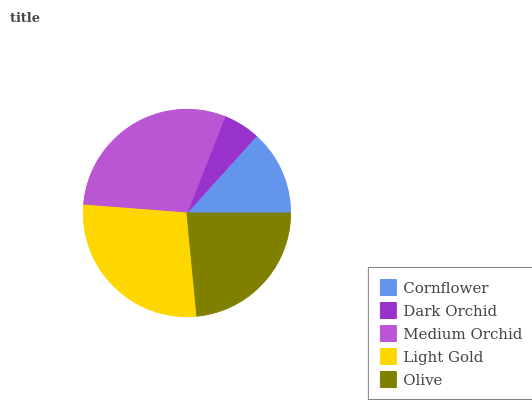Is Dark Orchid the minimum?
Answer yes or no. Yes. Is Medium Orchid the maximum?
Answer yes or no. Yes. Is Medium Orchid the minimum?
Answer yes or no. No. Is Dark Orchid the maximum?
Answer yes or no. No. Is Medium Orchid greater than Dark Orchid?
Answer yes or no. Yes. Is Dark Orchid less than Medium Orchid?
Answer yes or no. Yes. Is Dark Orchid greater than Medium Orchid?
Answer yes or no. No. Is Medium Orchid less than Dark Orchid?
Answer yes or no. No. Is Olive the high median?
Answer yes or no. Yes. Is Olive the low median?
Answer yes or no. Yes. Is Cornflower the high median?
Answer yes or no. No. Is Cornflower the low median?
Answer yes or no. No. 